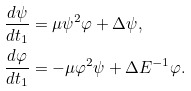<formula> <loc_0><loc_0><loc_500><loc_500>\frac { d \psi } { d t _ { 1 } } & = \mu \psi ^ { 2 } \varphi + \Delta \psi , \\ \frac { d \varphi } { d t _ { 1 } } & = - \mu \varphi ^ { 2 } \psi + \Delta E ^ { - 1 } \varphi .</formula> 